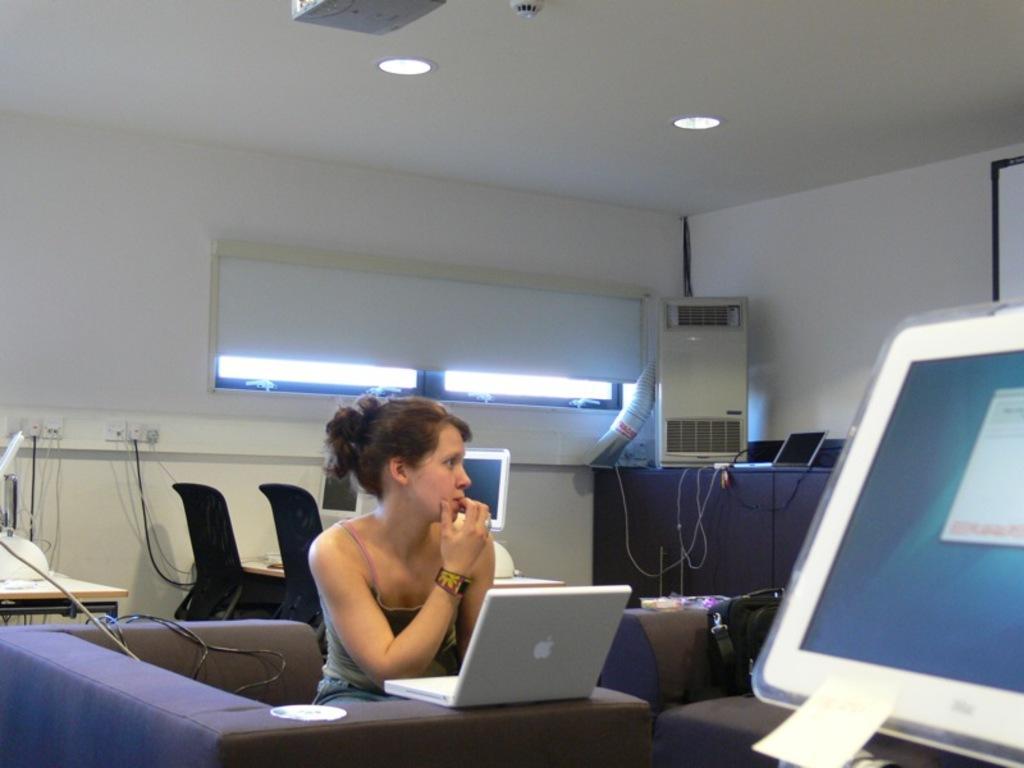Can you describe this image briefly? In this image we can see woman sitting at the sofa. On the sofa we can see a laptop. On the right of the image we can see monitor. In the background we can see chairs, table, monitor, air conditioner, laptop, screen, window and wall. 